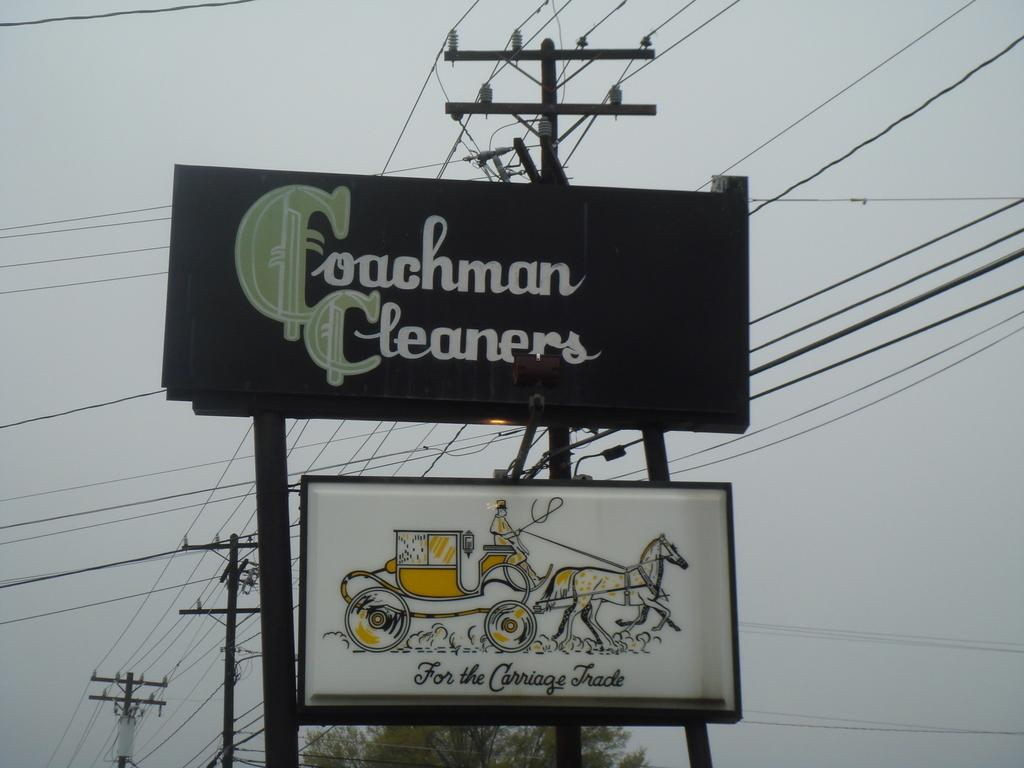<image>
Write a terse but informative summary of the picture. A coachman cleaners signboards is on top of another signboard with a horse and carriage on it. 